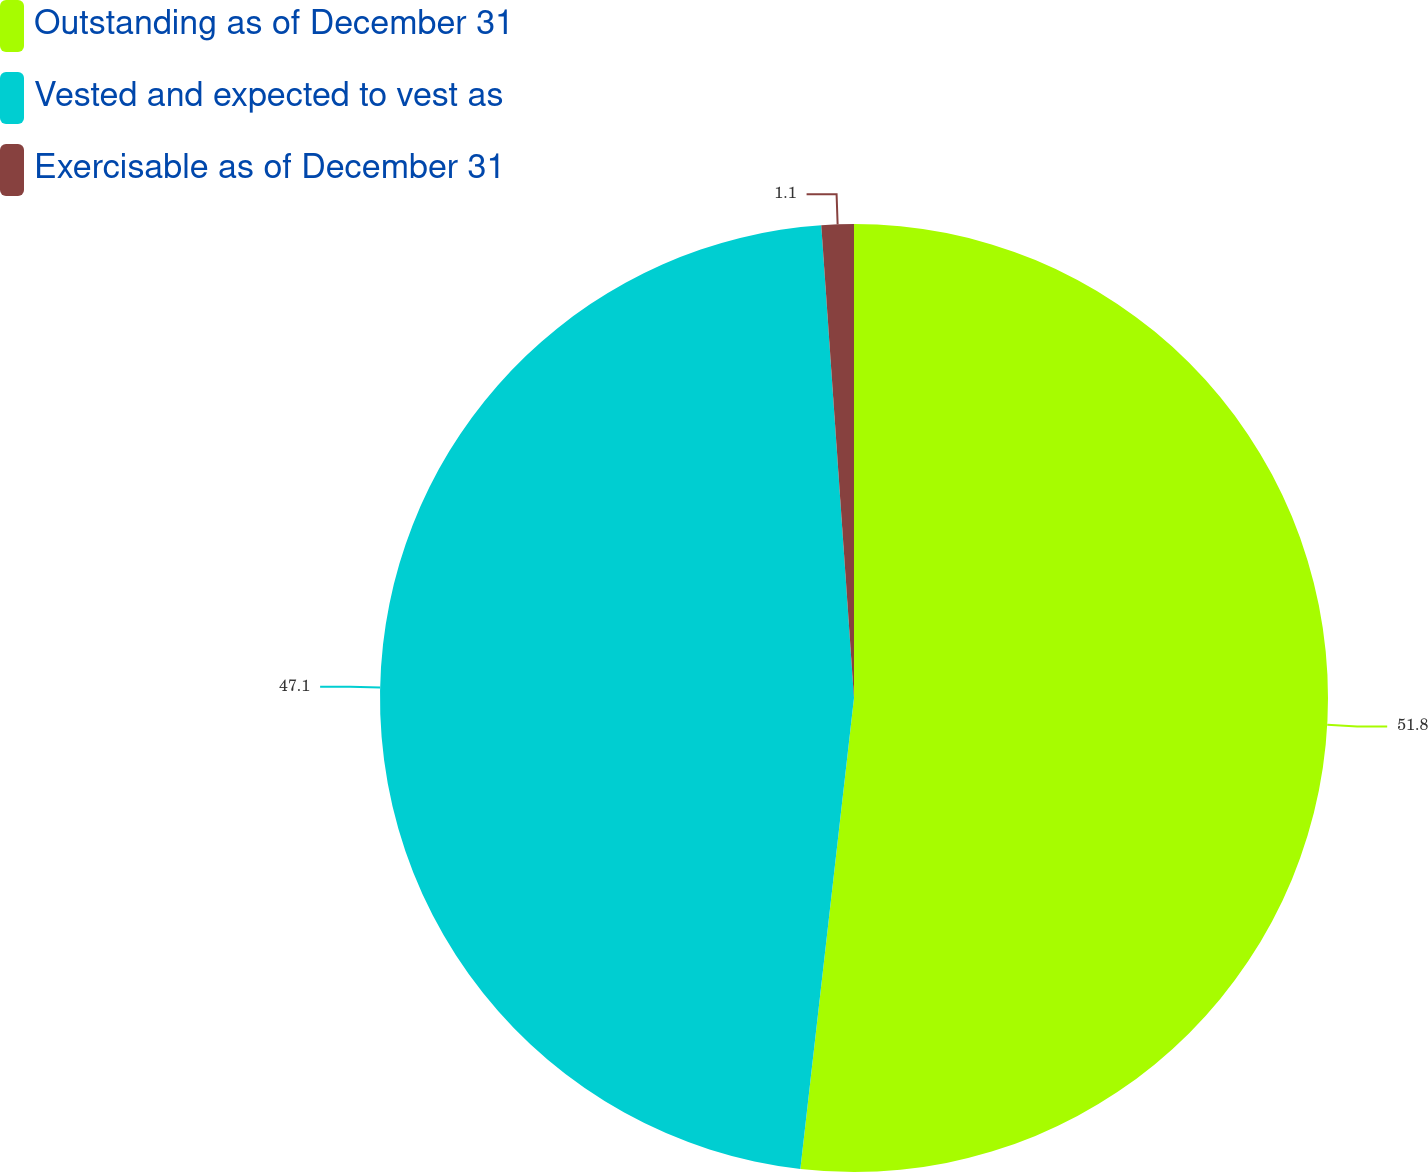Convert chart to OTSL. <chart><loc_0><loc_0><loc_500><loc_500><pie_chart><fcel>Outstanding as of December 31<fcel>Vested and expected to vest as<fcel>Exercisable as of December 31<nl><fcel>51.81%<fcel>47.1%<fcel>1.1%<nl></chart> 